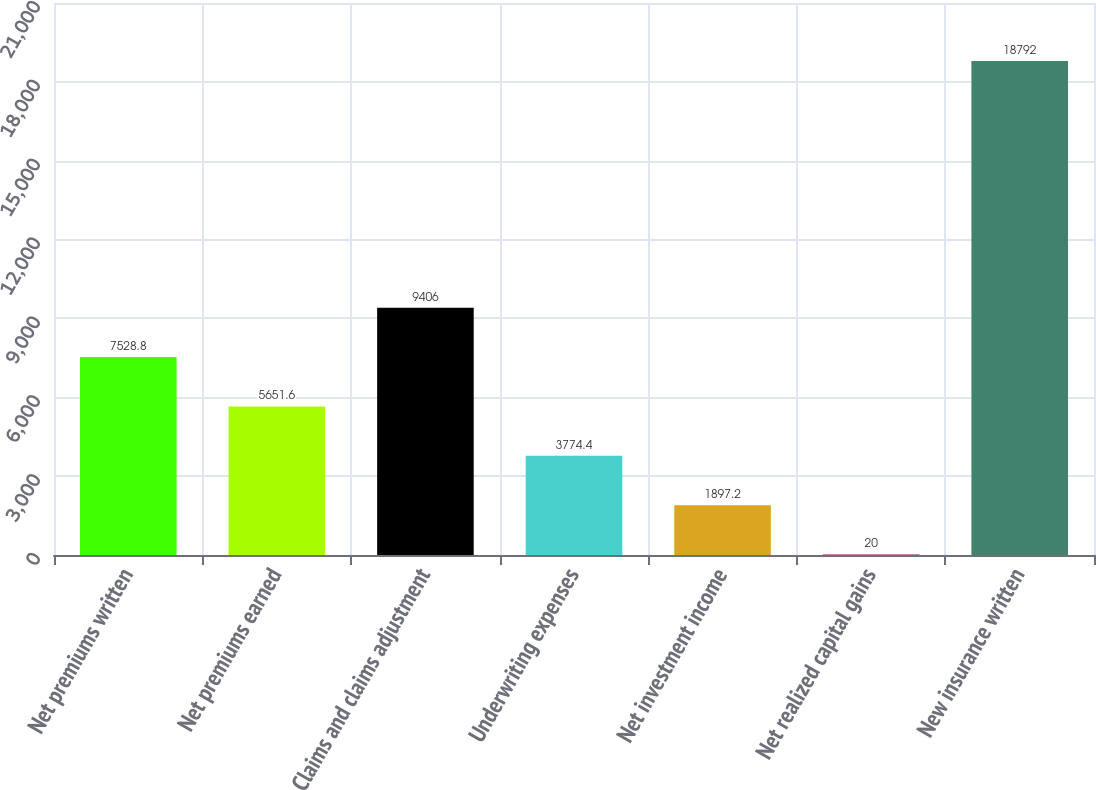Convert chart. <chart><loc_0><loc_0><loc_500><loc_500><bar_chart><fcel>Net premiums written<fcel>Net premiums earned<fcel>Claims and claims adjustment<fcel>Underwriting expenses<fcel>Net investment income<fcel>Net realized capital gains<fcel>New insurance written<nl><fcel>7528.8<fcel>5651.6<fcel>9406<fcel>3774.4<fcel>1897.2<fcel>20<fcel>18792<nl></chart> 